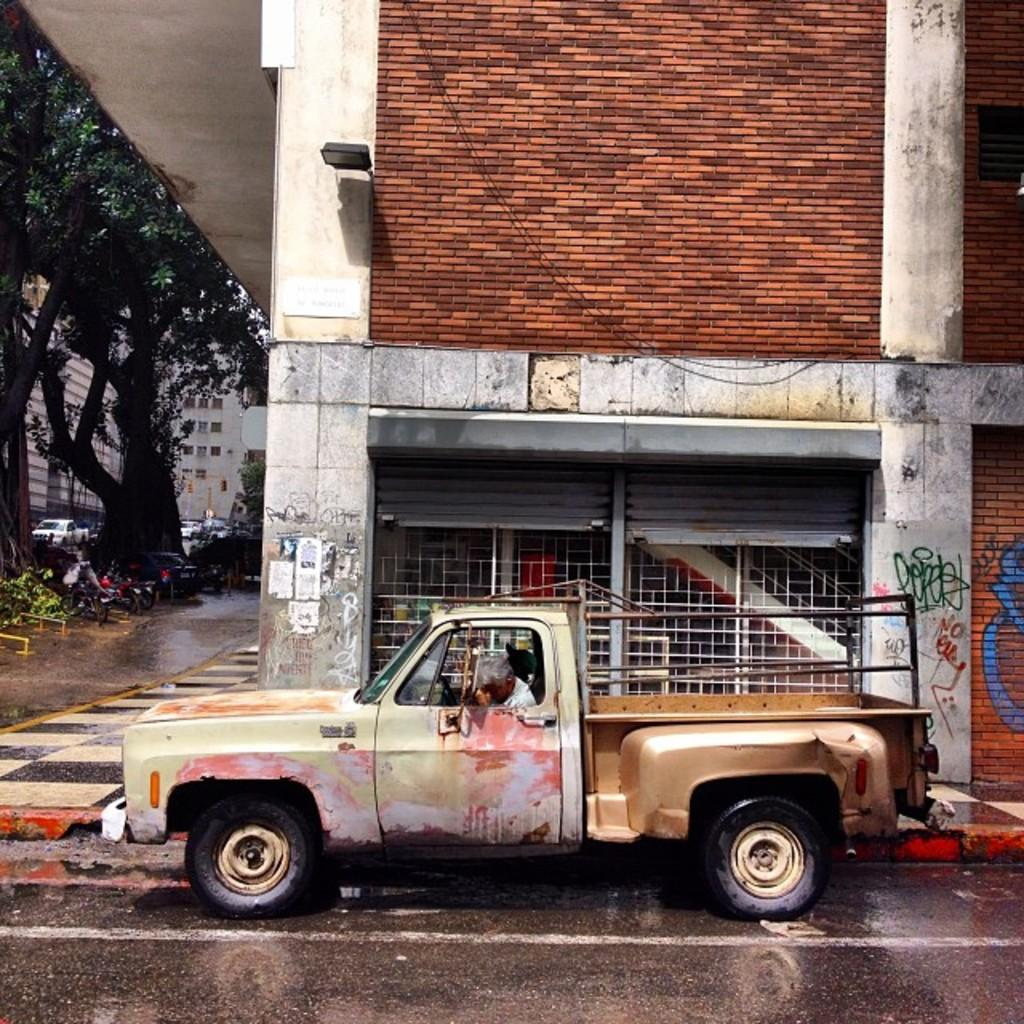What is on the road in the image? There is a vehicle on the road in the image. Who is inside the vehicle? A person is sitting in the vehicle. What can be seen on the left side of the image? There are trees on the left side of the image. What is visible in the background of the image? There are buildings in the background of the image. What type of brush can be seen in the image? There is no brush present in the image. What kind of fowl is visible in the image? There is no fowl present in the image. 